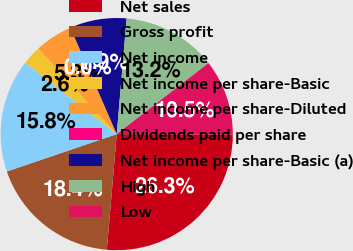Convert chart. <chart><loc_0><loc_0><loc_500><loc_500><pie_chart><fcel>Net sales<fcel>Gross profit<fcel>Net income<fcel>Net income per share-Basic<fcel>Net income per share-Diluted<fcel>Dividends paid per share<fcel>Net income per share-Basic (a)<fcel>High<fcel>Low<nl><fcel>26.32%<fcel>18.42%<fcel>15.79%<fcel>2.63%<fcel>5.26%<fcel>0.0%<fcel>7.89%<fcel>13.16%<fcel>10.53%<nl></chart> 